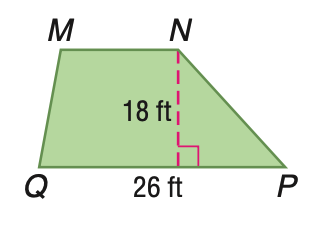Question: Trapezoid M N P Q has an area of 360 square feet. Find the length of M N.
Choices:
A. 14
B. 16
C. 18
D. 20
Answer with the letter. Answer: A 